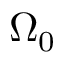<formula> <loc_0><loc_0><loc_500><loc_500>\Omega _ { 0 }</formula> 